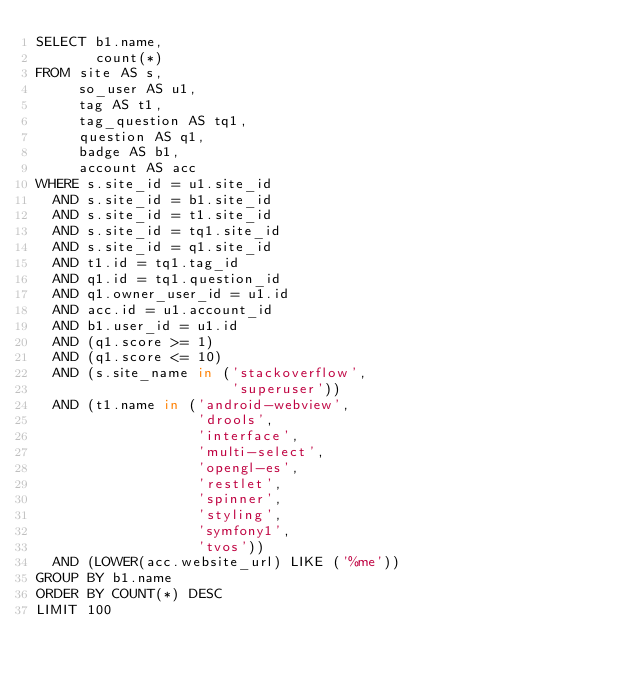<code> <loc_0><loc_0><loc_500><loc_500><_SQL_>SELECT b1.name,
       count(*)
FROM site AS s,
     so_user AS u1,
     tag AS t1,
     tag_question AS tq1,
     question AS q1,
     badge AS b1,
     account AS acc
WHERE s.site_id = u1.site_id
  AND s.site_id = b1.site_id
  AND s.site_id = t1.site_id
  AND s.site_id = tq1.site_id
  AND s.site_id = q1.site_id
  AND t1.id = tq1.tag_id
  AND q1.id = tq1.question_id
  AND q1.owner_user_id = u1.id
  AND acc.id = u1.account_id
  AND b1.user_id = u1.id
  AND (q1.score >= 1)
  AND (q1.score <= 10)
  AND (s.site_name in ('stackoverflow',
                       'superuser'))
  AND (t1.name in ('android-webview',
                   'drools',
                   'interface',
                   'multi-select',
                   'opengl-es',
                   'restlet',
                   'spinner',
                   'styling',
                   'symfony1',
                   'tvos'))
  AND (LOWER(acc.website_url) LIKE ('%me'))
GROUP BY b1.name
ORDER BY COUNT(*) DESC
LIMIT 100</code> 